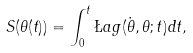<formula> <loc_0><loc_0><loc_500><loc_500>S ( \theta ( t ) ) = \int _ { 0 } ^ { t } \L a g ( \dot { \theta } , \theta ; t ) d t ,</formula> 